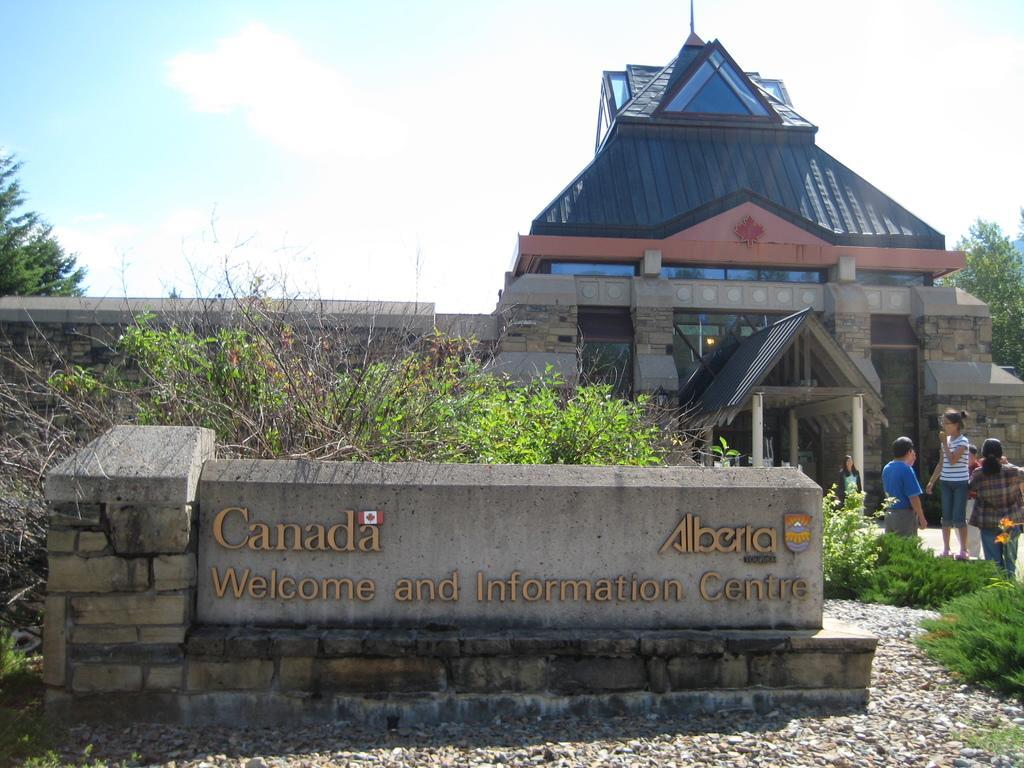In one or two sentences, can you explain what this image depicts? In this picture, it looks like a name board. Behind the name board, there are trees, building and the sky. On the right side of the image there is a group of people, grass and stones. 